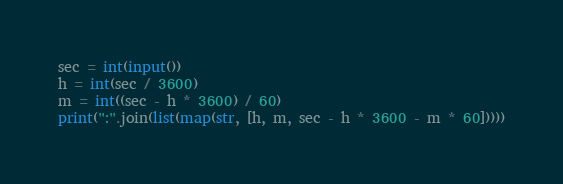<code> <loc_0><loc_0><loc_500><loc_500><_Python_>sec = int(input())
h = int(sec / 3600)
m = int((sec - h * 3600) / 60)
print(":".join(list(map(str, [h, m, sec - h * 3600 - m * 60]))))</code> 